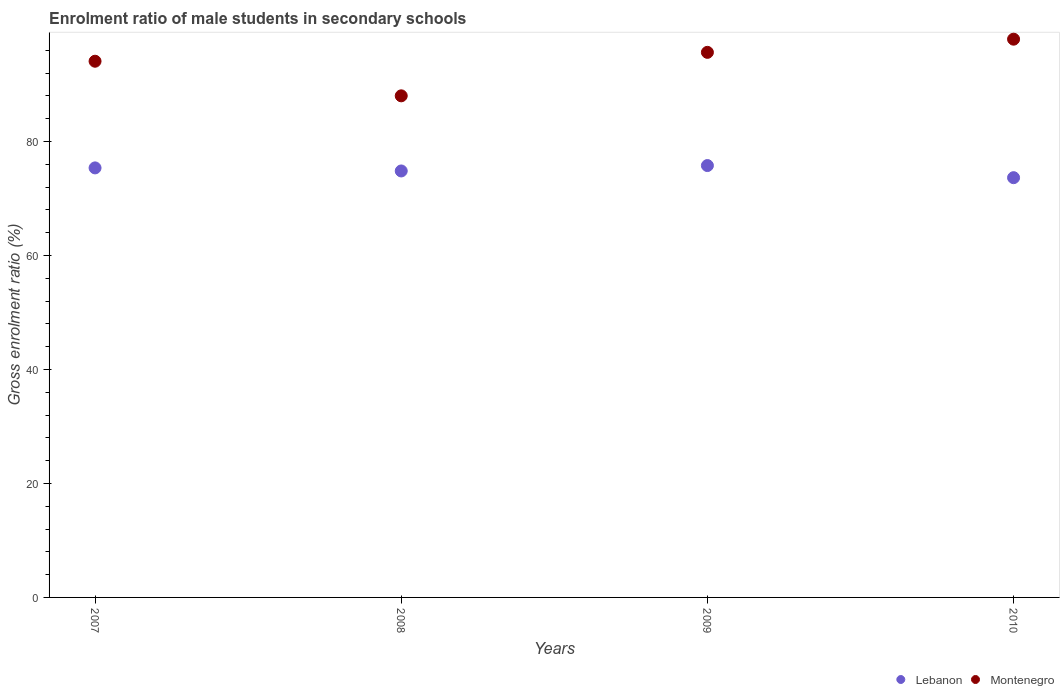Is the number of dotlines equal to the number of legend labels?
Offer a very short reply. Yes. What is the enrolment ratio of male students in secondary schools in Lebanon in 2008?
Your answer should be very brief. 74.82. Across all years, what is the maximum enrolment ratio of male students in secondary schools in Lebanon?
Your answer should be compact. 75.77. Across all years, what is the minimum enrolment ratio of male students in secondary schools in Lebanon?
Your answer should be compact. 73.64. In which year was the enrolment ratio of male students in secondary schools in Montenegro minimum?
Offer a terse response. 2008. What is the total enrolment ratio of male students in secondary schools in Montenegro in the graph?
Provide a succinct answer. 375.65. What is the difference between the enrolment ratio of male students in secondary schools in Lebanon in 2007 and that in 2008?
Ensure brevity in your answer.  0.54. What is the difference between the enrolment ratio of male students in secondary schools in Montenegro in 2009 and the enrolment ratio of male students in secondary schools in Lebanon in 2007?
Your response must be concise. 20.27. What is the average enrolment ratio of male students in secondary schools in Lebanon per year?
Provide a short and direct response. 74.9. In the year 2009, what is the difference between the enrolment ratio of male students in secondary schools in Lebanon and enrolment ratio of male students in secondary schools in Montenegro?
Provide a short and direct response. -19.86. What is the ratio of the enrolment ratio of male students in secondary schools in Lebanon in 2007 to that in 2010?
Offer a terse response. 1.02. Is the enrolment ratio of male students in secondary schools in Montenegro in 2007 less than that in 2010?
Offer a very short reply. Yes. Is the difference between the enrolment ratio of male students in secondary schools in Lebanon in 2007 and 2010 greater than the difference between the enrolment ratio of male students in secondary schools in Montenegro in 2007 and 2010?
Your answer should be compact. Yes. What is the difference between the highest and the second highest enrolment ratio of male students in secondary schools in Lebanon?
Make the answer very short. 0.41. What is the difference between the highest and the lowest enrolment ratio of male students in secondary schools in Lebanon?
Your answer should be very brief. 2.13. In how many years, is the enrolment ratio of male students in secondary schools in Montenegro greater than the average enrolment ratio of male students in secondary schools in Montenegro taken over all years?
Provide a succinct answer. 3. Is the sum of the enrolment ratio of male students in secondary schools in Montenegro in 2007 and 2010 greater than the maximum enrolment ratio of male students in secondary schools in Lebanon across all years?
Keep it short and to the point. Yes. Does the enrolment ratio of male students in secondary schools in Montenegro monotonically increase over the years?
Make the answer very short. No. Is the enrolment ratio of male students in secondary schools in Lebanon strictly greater than the enrolment ratio of male students in secondary schools in Montenegro over the years?
Give a very brief answer. No. How many dotlines are there?
Offer a terse response. 2. Are the values on the major ticks of Y-axis written in scientific E-notation?
Offer a very short reply. No. How many legend labels are there?
Your answer should be compact. 2. How are the legend labels stacked?
Provide a short and direct response. Horizontal. What is the title of the graph?
Your response must be concise. Enrolment ratio of male students in secondary schools. What is the label or title of the Y-axis?
Provide a succinct answer. Gross enrolment ratio (%). What is the Gross enrolment ratio (%) of Lebanon in 2007?
Make the answer very short. 75.36. What is the Gross enrolment ratio (%) of Montenegro in 2007?
Offer a terse response. 94.07. What is the Gross enrolment ratio (%) of Lebanon in 2008?
Provide a succinct answer. 74.82. What is the Gross enrolment ratio (%) of Montenegro in 2008?
Offer a very short reply. 88. What is the Gross enrolment ratio (%) of Lebanon in 2009?
Your response must be concise. 75.77. What is the Gross enrolment ratio (%) in Montenegro in 2009?
Offer a very short reply. 95.63. What is the Gross enrolment ratio (%) in Lebanon in 2010?
Provide a succinct answer. 73.64. What is the Gross enrolment ratio (%) in Montenegro in 2010?
Offer a terse response. 97.94. Across all years, what is the maximum Gross enrolment ratio (%) of Lebanon?
Provide a succinct answer. 75.77. Across all years, what is the maximum Gross enrolment ratio (%) in Montenegro?
Make the answer very short. 97.94. Across all years, what is the minimum Gross enrolment ratio (%) in Lebanon?
Provide a succinct answer. 73.64. Across all years, what is the minimum Gross enrolment ratio (%) in Montenegro?
Give a very brief answer. 88. What is the total Gross enrolment ratio (%) of Lebanon in the graph?
Your answer should be very brief. 299.59. What is the total Gross enrolment ratio (%) of Montenegro in the graph?
Offer a terse response. 375.65. What is the difference between the Gross enrolment ratio (%) in Lebanon in 2007 and that in 2008?
Provide a short and direct response. 0.54. What is the difference between the Gross enrolment ratio (%) in Montenegro in 2007 and that in 2008?
Provide a succinct answer. 6.07. What is the difference between the Gross enrolment ratio (%) of Lebanon in 2007 and that in 2009?
Your response must be concise. -0.41. What is the difference between the Gross enrolment ratio (%) in Montenegro in 2007 and that in 2009?
Your answer should be very brief. -1.56. What is the difference between the Gross enrolment ratio (%) of Lebanon in 2007 and that in 2010?
Your answer should be compact. 1.72. What is the difference between the Gross enrolment ratio (%) in Montenegro in 2007 and that in 2010?
Give a very brief answer. -3.87. What is the difference between the Gross enrolment ratio (%) in Lebanon in 2008 and that in 2009?
Offer a very short reply. -0.95. What is the difference between the Gross enrolment ratio (%) in Montenegro in 2008 and that in 2009?
Your response must be concise. -7.63. What is the difference between the Gross enrolment ratio (%) of Lebanon in 2008 and that in 2010?
Keep it short and to the point. 1.18. What is the difference between the Gross enrolment ratio (%) of Montenegro in 2008 and that in 2010?
Provide a short and direct response. -9.94. What is the difference between the Gross enrolment ratio (%) in Lebanon in 2009 and that in 2010?
Offer a very short reply. 2.13. What is the difference between the Gross enrolment ratio (%) in Montenegro in 2009 and that in 2010?
Give a very brief answer. -2.31. What is the difference between the Gross enrolment ratio (%) of Lebanon in 2007 and the Gross enrolment ratio (%) of Montenegro in 2008?
Give a very brief answer. -12.64. What is the difference between the Gross enrolment ratio (%) in Lebanon in 2007 and the Gross enrolment ratio (%) in Montenegro in 2009?
Your answer should be very brief. -20.27. What is the difference between the Gross enrolment ratio (%) in Lebanon in 2007 and the Gross enrolment ratio (%) in Montenegro in 2010?
Make the answer very short. -22.58. What is the difference between the Gross enrolment ratio (%) in Lebanon in 2008 and the Gross enrolment ratio (%) in Montenegro in 2009?
Offer a terse response. -20.81. What is the difference between the Gross enrolment ratio (%) in Lebanon in 2008 and the Gross enrolment ratio (%) in Montenegro in 2010?
Your answer should be compact. -23.12. What is the difference between the Gross enrolment ratio (%) in Lebanon in 2009 and the Gross enrolment ratio (%) in Montenegro in 2010?
Ensure brevity in your answer.  -22.17. What is the average Gross enrolment ratio (%) in Lebanon per year?
Your answer should be compact. 74.9. What is the average Gross enrolment ratio (%) in Montenegro per year?
Offer a terse response. 93.91. In the year 2007, what is the difference between the Gross enrolment ratio (%) of Lebanon and Gross enrolment ratio (%) of Montenegro?
Your answer should be very brief. -18.71. In the year 2008, what is the difference between the Gross enrolment ratio (%) in Lebanon and Gross enrolment ratio (%) in Montenegro?
Your answer should be very brief. -13.18. In the year 2009, what is the difference between the Gross enrolment ratio (%) of Lebanon and Gross enrolment ratio (%) of Montenegro?
Offer a terse response. -19.86. In the year 2010, what is the difference between the Gross enrolment ratio (%) in Lebanon and Gross enrolment ratio (%) in Montenegro?
Your answer should be compact. -24.3. What is the ratio of the Gross enrolment ratio (%) of Lebanon in 2007 to that in 2008?
Your response must be concise. 1.01. What is the ratio of the Gross enrolment ratio (%) in Montenegro in 2007 to that in 2008?
Ensure brevity in your answer.  1.07. What is the ratio of the Gross enrolment ratio (%) of Montenegro in 2007 to that in 2009?
Ensure brevity in your answer.  0.98. What is the ratio of the Gross enrolment ratio (%) of Lebanon in 2007 to that in 2010?
Provide a succinct answer. 1.02. What is the ratio of the Gross enrolment ratio (%) in Montenegro in 2007 to that in 2010?
Give a very brief answer. 0.96. What is the ratio of the Gross enrolment ratio (%) of Lebanon in 2008 to that in 2009?
Give a very brief answer. 0.99. What is the ratio of the Gross enrolment ratio (%) of Montenegro in 2008 to that in 2009?
Your answer should be very brief. 0.92. What is the ratio of the Gross enrolment ratio (%) in Lebanon in 2008 to that in 2010?
Offer a very short reply. 1.02. What is the ratio of the Gross enrolment ratio (%) of Montenegro in 2008 to that in 2010?
Offer a terse response. 0.9. What is the ratio of the Gross enrolment ratio (%) in Lebanon in 2009 to that in 2010?
Provide a short and direct response. 1.03. What is the ratio of the Gross enrolment ratio (%) in Montenegro in 2009 to that in 2010?
Keep it short and to the point. 0.98. What is the difference between the highest and the second highest Gross enrolment ratio (%) of Lebanon?
Your answer should be very brief. 0.41. What is the difference between the highest and the second highest Gross enrolment ratio (%) of Montenegro?
Give a very brief answer. 2.31. What is the difference between the highest and the lowest Gross enrolment ratio (%) in Lebanon?
Your answer should be compact. 2.13. What is the difference between the highest and the lowest Gross enrolment ratio (%) in Montenegro?
Offer a terse response. 9.94. 